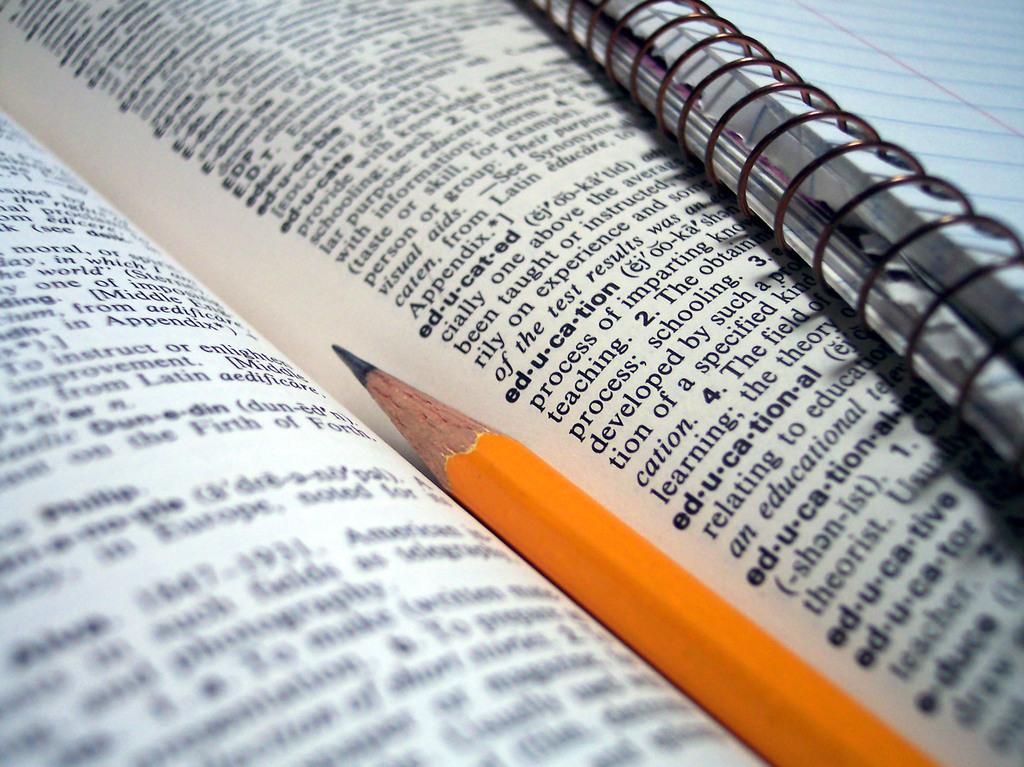What word is next to the point on this pencil?
Your response must be concise. Educated. What language is discussed above the definition for educated?
Give a very brief answer. Latin. 